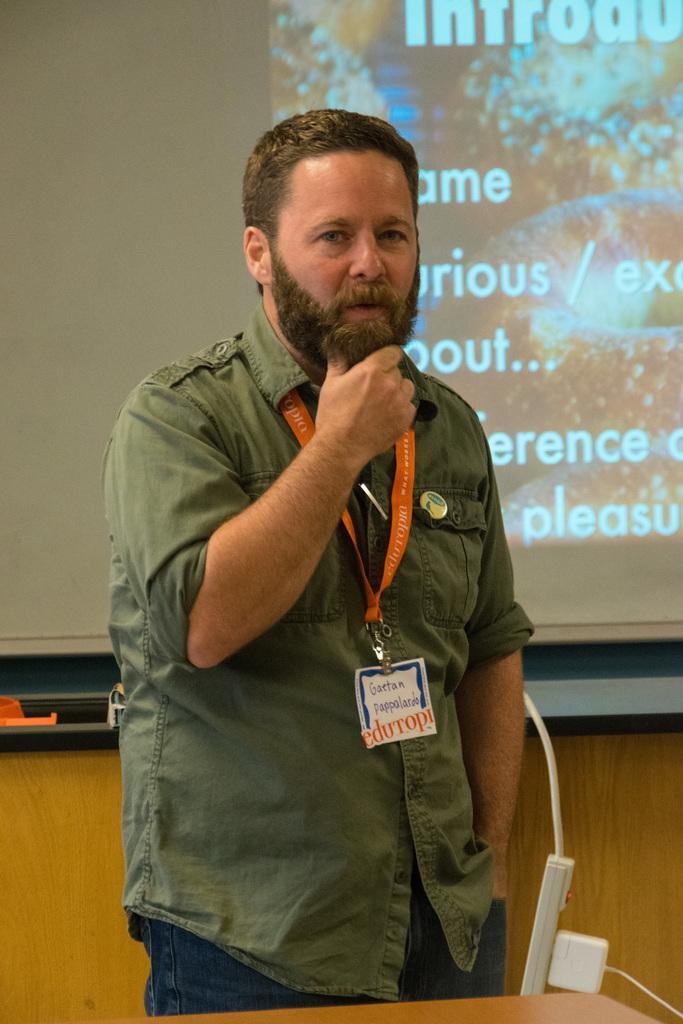How would you summarize this image in a sentence or two? In this picture I can see a man standing and he is wearing a ID card and looks like a projector screen in the back, displaying some text and I can see a table at the bottom of the picture and I can see a socket board at the bottom right corner. 